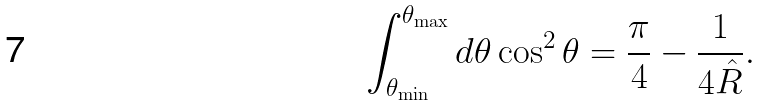<formula> <loc_0><loc_0><loc_500><loc_500>\int _ { \theta _ { \min } } ^ { \theta _ { \max } } { d \theta } \cos ^ { 2 } \theta = \frac { \pi } { 4 } - \frac { 1 } { 4 \hat { R } } .</formula> 